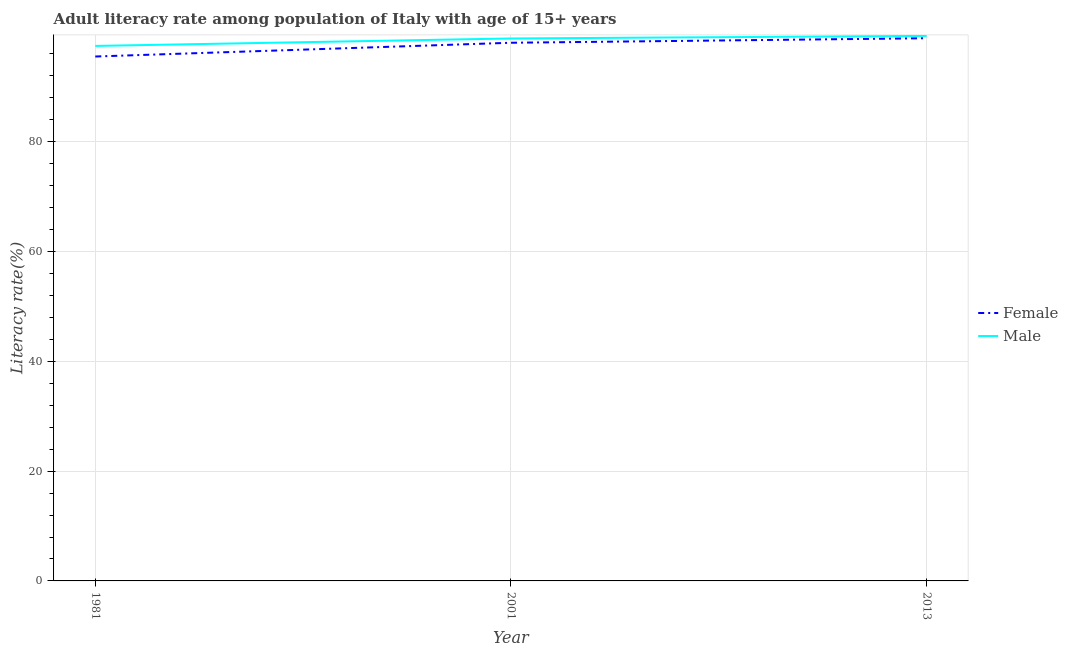What is the male adult literacy rate in 2001?
Provide a succinct answer. 98.82. Across all years, what is the maximum male adult literacy rate?
Provide a succinct answer. 99.29. Across all years, what is the minimum male adult literacy rate?
Make the answer very short. 97.46. What is the total male adult literacy rate in the graph?
Provide a short and direct response. 295.58. What is the difference between the female adult literacy rate in 1981 and that in 2013?
Your answer should be compact. -3.33. What is the difference between the male adult literacy rate in 1981 and the female adult literacy rate in 2013?
Your response must be concise. -1.4. What is the average female adult literacy rate per year?
Ensure brevity in your answer.  97.48. In the year 2013, what is the difference between the female adult literacy rate and male adult literacy rate?
Make the answer very short. -0.42. In how many years, is the male adult literacy rate greater than 64 %?
Your answer should be compact. 3. What is the ratio of the male adult literacy rate in 2001 to that in 2013?
Ensure brevity in your answer.  1. Is the female adult literacy rate in 1981 less than that in 2001?
Provide a succinct answer. Yes. Is the difference between the female adult literacy rate in 1981 and 2001 greater than the difference between the male adult literacy rate in 1981 and 2001?
Make the answer very short. No. What is the difference between the highest and the second highest male adult literacy rate?
Your answer should be very brief. 0.47. What is the difference between the highest and the lowest female adult literacy rate?
Keep it short and to the point. 3.33. Is the sum of the female adult literacy rate in 1981 and 2001 greater than the maximum male adult literacy rate across all years?
Your answer should be compact. Yes. How many lines are there?
Give a very brief answer. 2. How many years are there in the graph?
Offer a terse response. 3. Are the values on the major ticks of Y-axis written in scientific E-notation?
Provide a short and direct response. No. Does the graph contain any zero values?
Offer a terse response. No. Where does the legend appear in the graph?
Keep it short and to the point. Center right. How many legend labels are there?
Offer a very short reply. 2. How are the legend labels stacked?
Your answer should be compact. Vertical. What is the title of the graph?
Provide a short and direct response. Adult literacy rate among population of Italy with age of 15+ years. What is the label or title of the Y-axis?
Your response must be concise. Literacy rate(%). What is the Literacy rate(%) in Female in 1981?
Make the answer very short. 95.54. What is the Literacy rate(%) of Male in 1981?
Ensure brevity in your answer.  97.46. What is the Literacy rate(%) in Female in 2001?
Provide a short and direct response. 98.04. What is the Literacy rate(%) of Male in 2001?
Your answer should be very brief. 98.82. What is the Literacy rate(%) of Female in 2013?
Your answer should be compact. 98.87. What is the Literacy rate(%) of Male in 2013?
Your response must be concise. 99.29. Across all years, what is the maximum Literacy rate(%) in Female?
Offer a terse response. 98.87. Across all years, what is the maximum Literacy rate(%) in Male?
Offer a very short reply. 99.29. Across all years, what is the minimum Literacy rate(%) in Female?
Give a very brief answer. 95.54. Across all years, what is the minimum Literacy rate(%) in Male?
Your response must be concise. 97.46. What is the total Literacy rate(%) of Female in the graph?
Keep it short and to the point. 292.45. What is the total Literacy rate(%) in Male in the graph?
Your answer should be very brief. 295.58. What is the difference between the Literacy rate(%) in Female in 1981 and that in 2001?
Provide a succinct answer. -2.51. What is the difference between the Literacy rate(%) in Male in 1981 and that in 2001?
Provide a succinct answer. -1.36. What is the difference between the Literacy rate(%) of Female in 1981 and that in 2013?
Keep it short and to the point. -3.33. What is the difference between the Literacy rate(%) in Male in 1981 and that in 2013?
Give a very brief answer. -1.83. What is the difference between the Literacy rate(%) in Female in 2001 and that in 2013?
Your answer should be very brief. -0.82. What is the difference between the Literacy rate(%) in Male in 2001 and that in 2013?
Provide a succinct answer. -0.47. What is the difference between the Literacy rate(%) of Female in 1981 and the Literacy rate(%) of Male in 2001?
Ensure brevity in your answer.  -3.29. What is the difference between the Literacy rate(%) in Female in 1981 and the Literacy rate(%) in Male in 2013?
Your answer should be compact. -3.75. What is the difference between the Literacy rate(%) of Female in 2001 and the Literacy rate(%) of Male in 2013?
Provide a succinct answer. -1.25. What is the average Literacy rate(%) of Female per year?
Your answer should be very brief. 97.48. What is the average Literacy rate(%) of Male per year?
Provide a succinct answer. 98.53. In the year 1981, what is the difference between the Literacy rate(%) in Female and Literacy rate(%) in Male?
Your answer should be very brief. -1.93. In the year 2001, what is the difference between the Literacy rate(%) of Female and Literacy rate(%) of Male?
Provide a succinct answer. -0.78. In the year 2013, what is the difference between the Literacy rate(%) in Female and Literacy rate(%) in Male?
Provide a short and direct response. -0.42. What is the ratio of the Literacy rate(%) of Female in 1981 to that in 2001?
Your answer should be compact. 0.97. What is the ratio of the Literacy rate(%) of Male in 1981 to that in 2001?
Provide a short and direct response. 0.99. What is the ratio of the Literacy rate(%) of Female in 1981 to that in 2013?
Your answer should be very brief. 0.97. What is the ratio of the Literacy rate(%) of Male in 1981 to that in 2013?
Your response must be concise. 0.98. What is the ratio of the Literacy rate(%) of Female in 2001 to that in 2013?
Provide a succinct answer. 0.99. What is the difference between the highest and the second highest Literacy rate(%) of Female?
Your answer should be very brief. 0.82. What is the difference between the highest and the second highest Literacy rate(%) in Male?
Offer a very short reply. 0.47. What is the difference between the highest and the lowest Literacy rate(%) in Female?
Provide a short and direct response. 3.33. What is the difference between the highest and the lowest Literacy rate(%) of Male?
Provide a succinct answer. 1.83. 